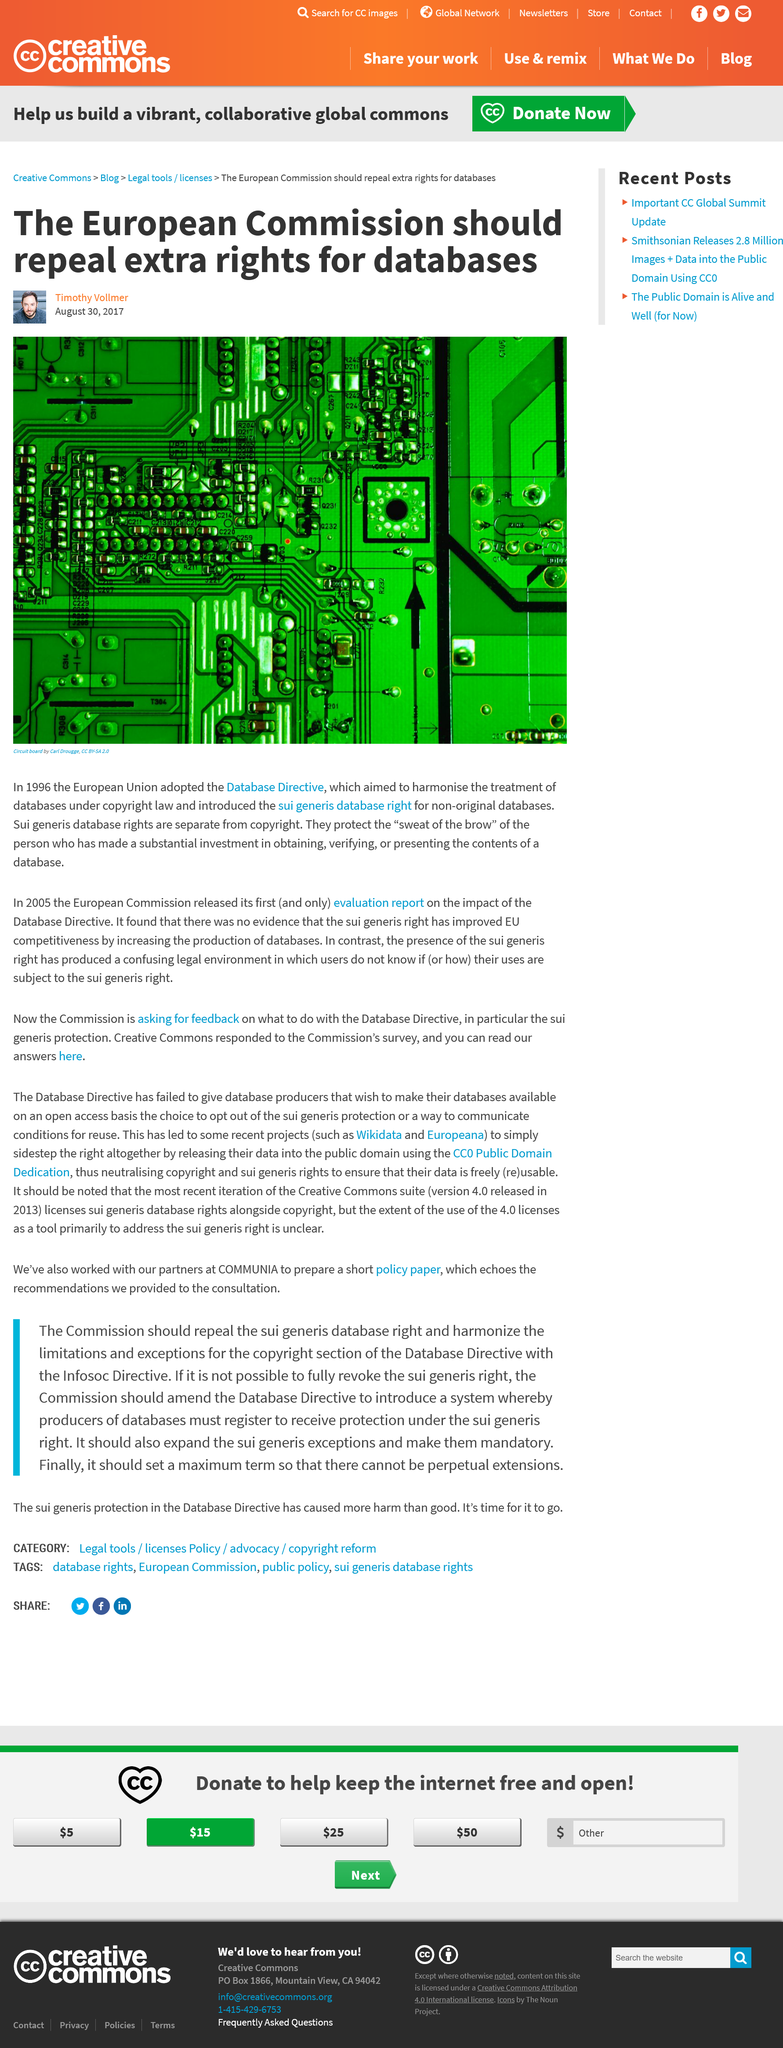Specify some key components in this picture. The top image is a circuit board. The European Union adopted the Database Directive in 1996. The Database Directive aimed to harmonize the treatment of databases under copyright law and introduced a sui generis database right for non-original databases. 